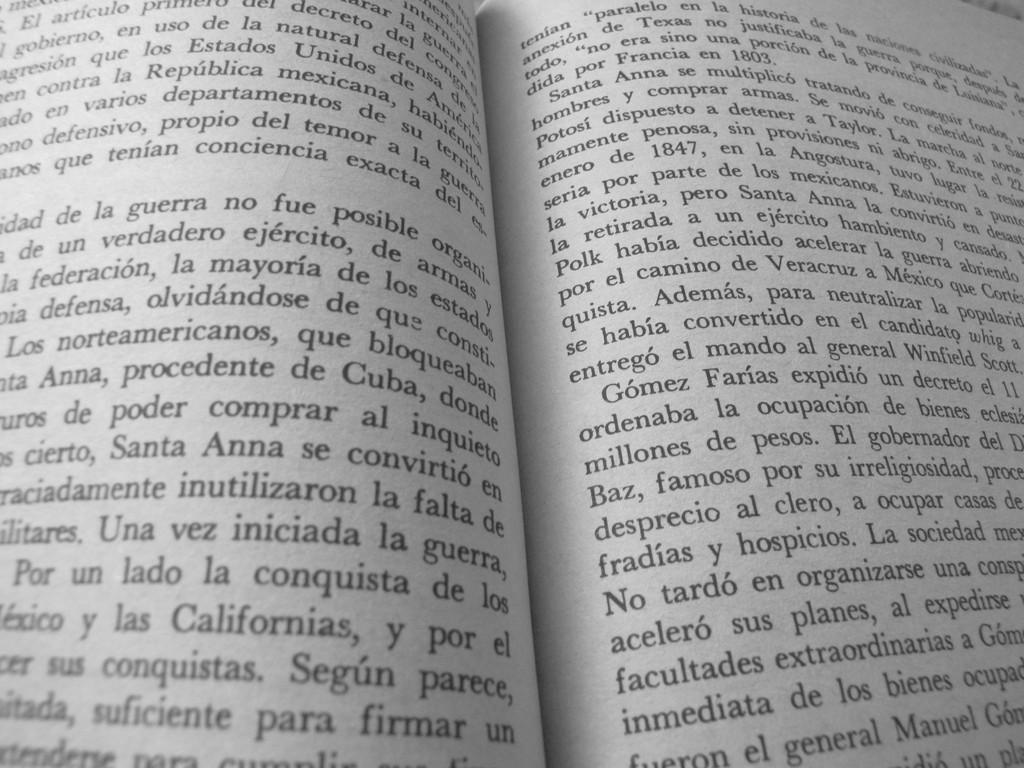<image>
Describe the image concisely. The first full paragraph on the second page of an open book begins with the words "Santa Anna se multiplico". 